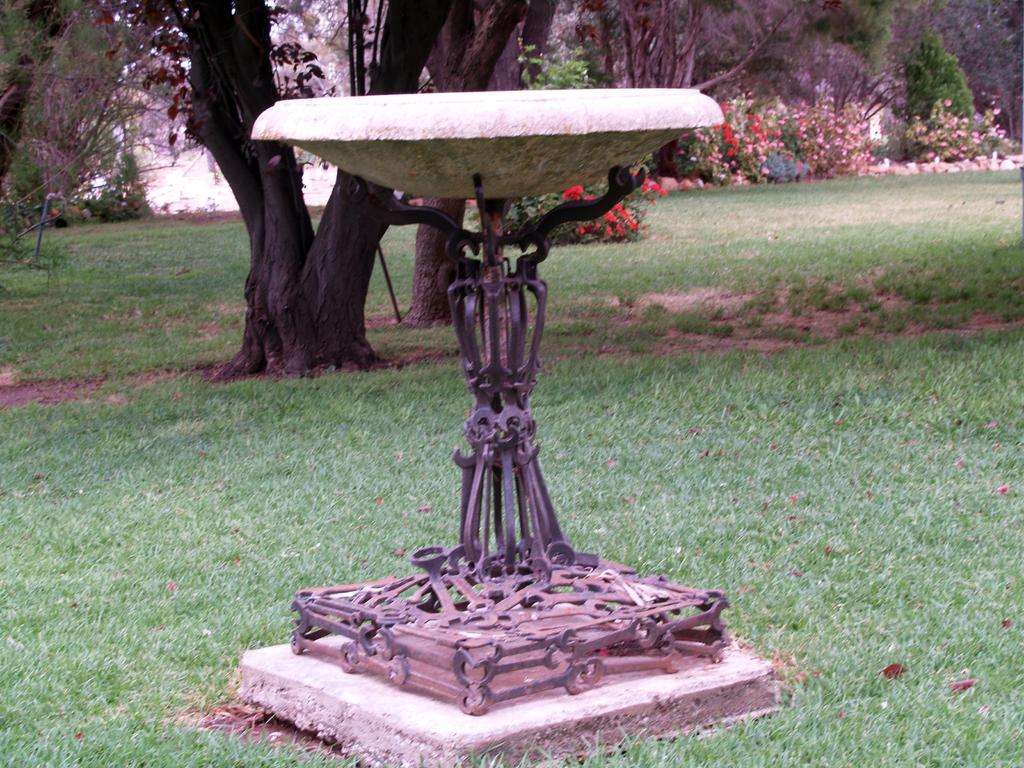Can you describe this image briefly? In this picture I can observe a fountain placed on the ground. There is some grass on the ground. In the background there are trees, plants and some flowers to these plants. 